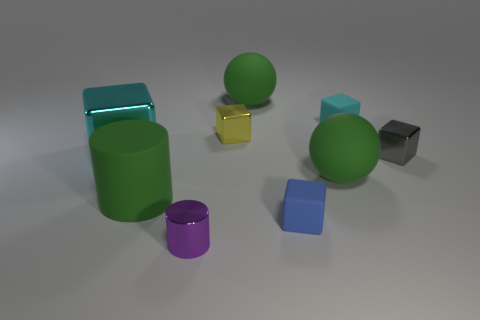Subtract all matte blocks. How many blocks are left? 3 Add 1 green balls. How many objects exist? 10 Subtract all blue blocks. How many blocks are left? 4 Subtract 2 blocks. How many blocks are left? 3 Subtract all blue cylinders. How many blue cubes are left? 1 Subtract all tiny metallic cylinders. Subtract all big matte objects. How many objects are left? 5 Add 9 big cyan objects. How many big cyan objects are left? 10 Add 9 tiny purple shiny objects. How many tiny purple shiny objects exist? 10 Subtract 0 purple balls. How many objects are left? 9 Subtract all cylinders. How many objects are left? 7 